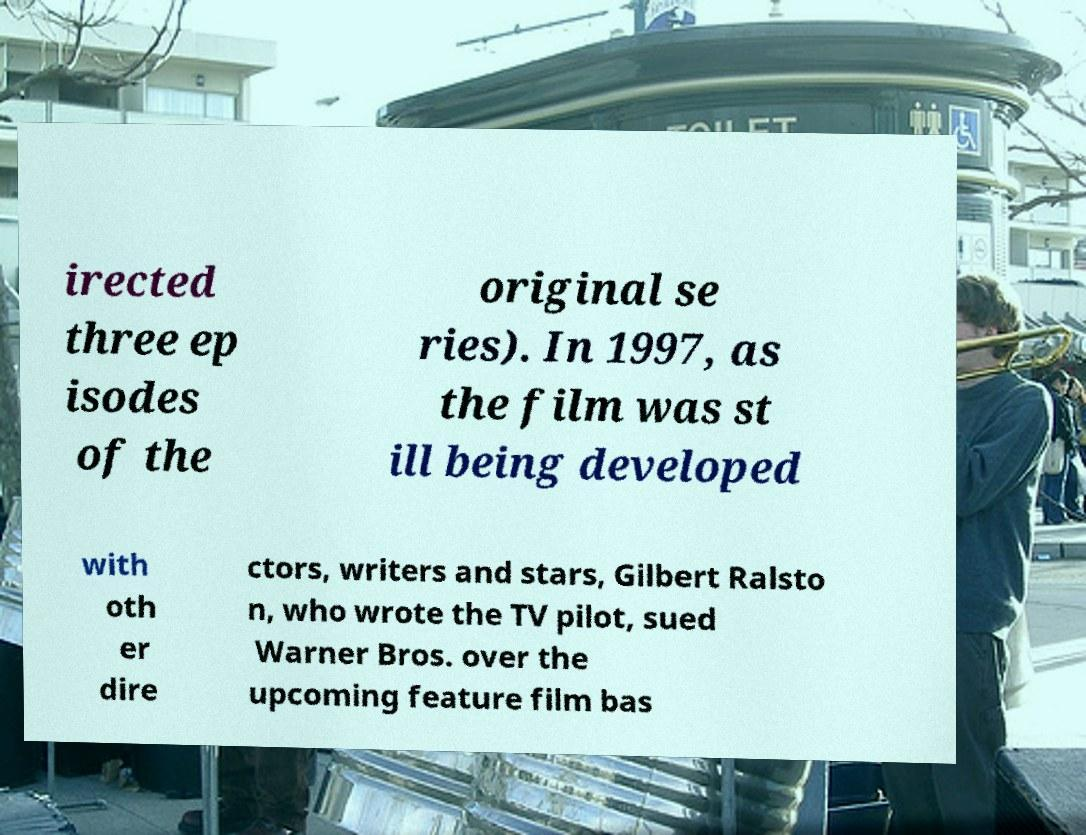Could you assist in decoding the text presented in this image and type it out clearly? irected three ep isodes of the original se ries). In 1997, as the film was st ill being developed with oth er dire ctors, writers and stars, Gilbert Ralsto n, who wrote the TV pilot, sued Warner Bros. over the upcoming feature film bas 